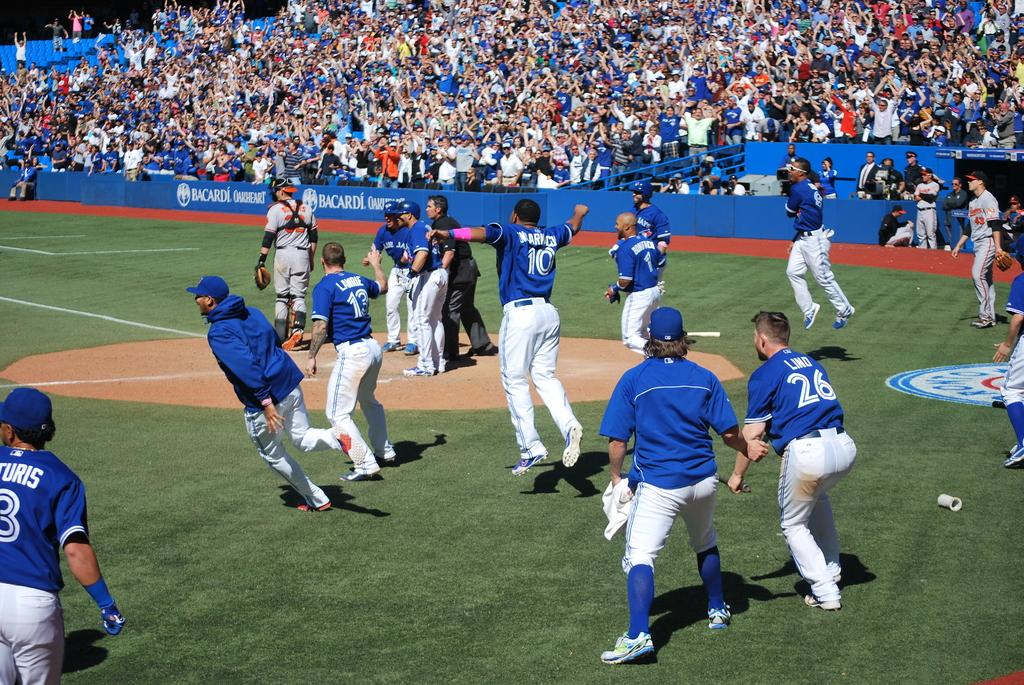<image>
Give a short and clear explanation of the subsequent image. some Blue Jays players with one wearing the number 26 